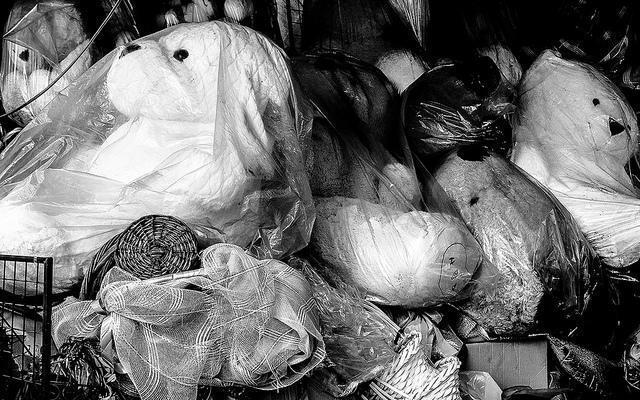How many teddy bears are there?
Give a very brief answer. 6. 